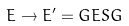<formula> <loc_0><loc_0><loc_500><loc_500>E \rightarrow E ^ { \prime } = G E S G</formula> 